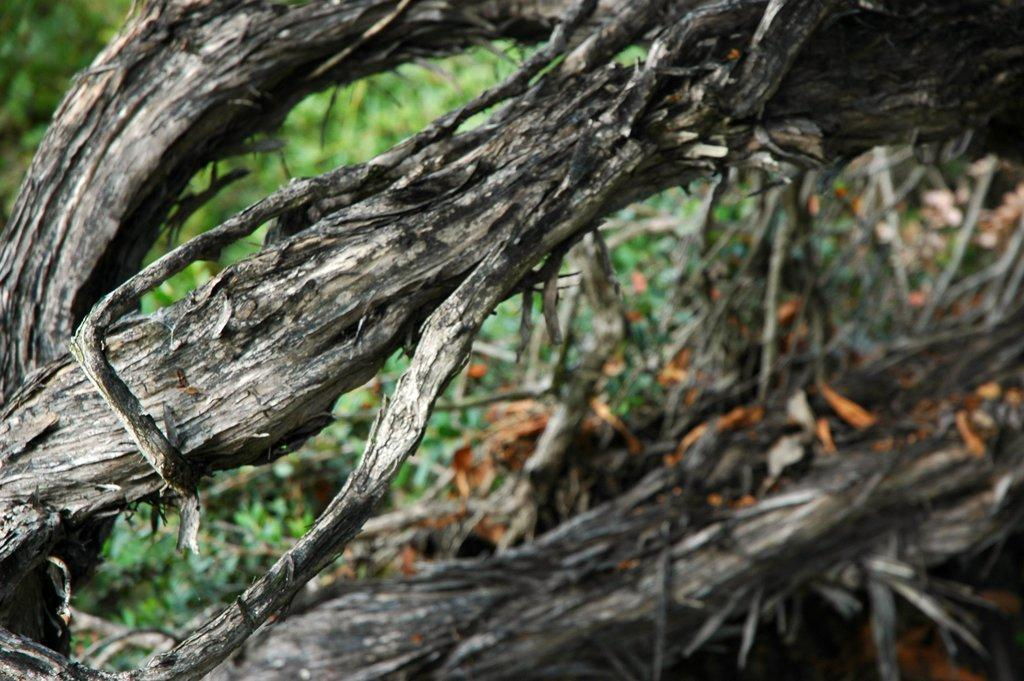What type of material is the main subject of the image made of? The main subject of the image is made of dried wood. Can you describe the background of the image? The background of the image is blurred. What type of bell can be heard ringing in the image? There is no bell present in the image, and therefore no sound can be heard. 